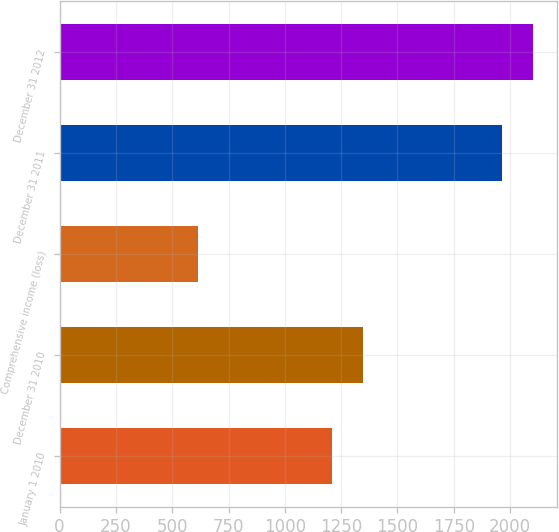Convert chart to OTSL. <chart><loc_0><loc_0><loc_500><loc_500><bar_chart><fcel>January 1 2010<fcel>December 31 2010<fcel>Comprehensive income (loss)<fcel>December 31 2011<fcel>December 31 2012<nl><fcel>1208<fcel>1348<fcel>616<fcel>1964<fcel>2101.4<nl></chart> 